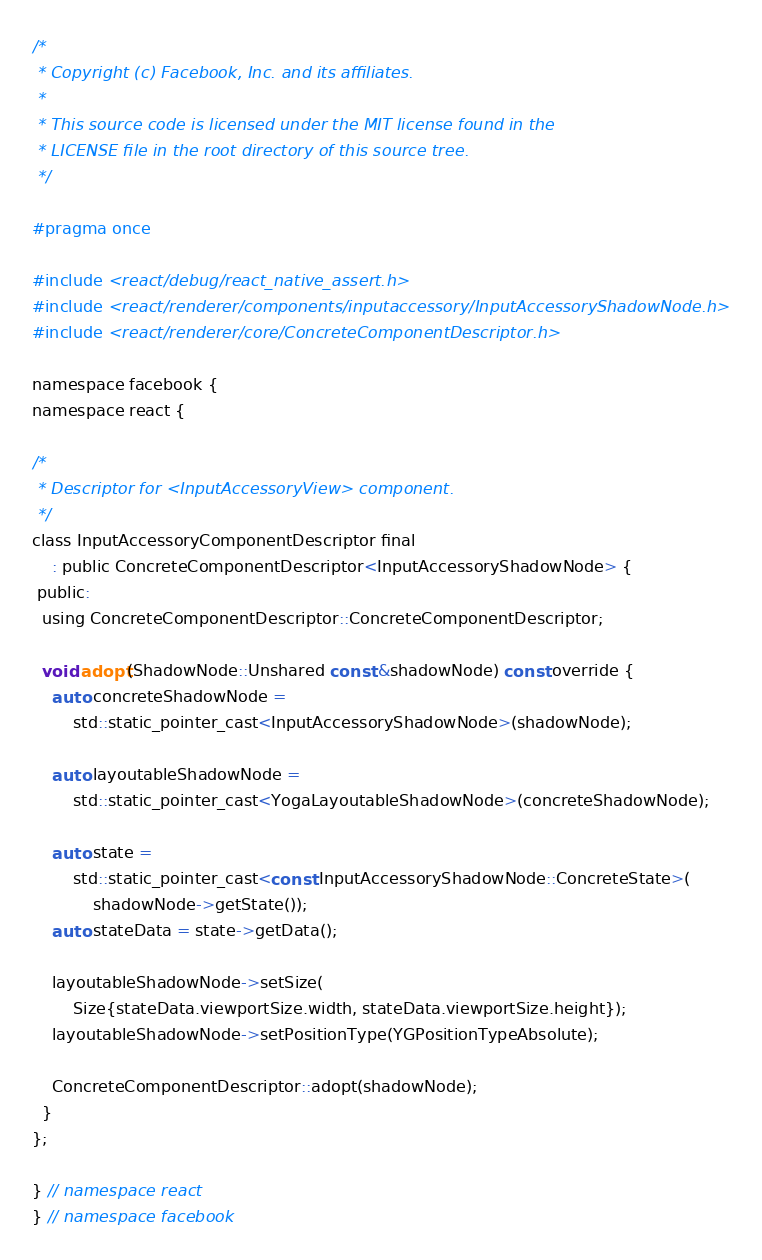<code> <loc_0><loc_0><loc_500><loc_500><_C_>/*
 * Copyright (c) Facebook, Inc. and its affiliates.
 *
 * This source code is licensed under the MIT license found in the
 * LICENSE file in the root directory of this source tree.
 */

#pragma once

#include <react/debug/react_native_assert.h>
#include <react/renderer/components/inputaccessory/InputAccessoryShadowNode.h>
#include <react/renderer/core/ConcreteComponentDescriptor.h>

namespace facebook {
namespace react {

/*
 * Descriptor for <InputAccessoryView> component.
 */
class InputAccessoryComponentDescriptor final
    : public ConcreteComponentDescriptor<InputAccessoryShadowNode> {
 public:
  using ConcreteComponentDescriptor::ConcreteComponentDescriptor;

  void adopt(ShadowNode::Unshared const &shadowNode) const override {
    auto concreteShadowNode =
        std::static_pointer_cast<InputAccessoryShadowNode>(shadowNode);

    auto layoutableShadowNode =
        std::static_pointer_cast<YogaLayoutableShadowNode>(concreteShadowNode);

    auto state =
        std::static_pointer_cast<const InputAccessoryShadowNode::ConcreteState>(
            shadowNode->getState());
    auto stateData = state->getData();

    layoutableShadowNode->setSize(
        Size{stateData.viewportSize.width, stateData.viewportSize.height});
    layoutableShadowNode->setPositionType(YGPositionTypeAbsolute);

    ConcreteComponentDescriptor::adopt(shadowNode);
  }
};

} // namespace react
} // namespace facebook
</code> 